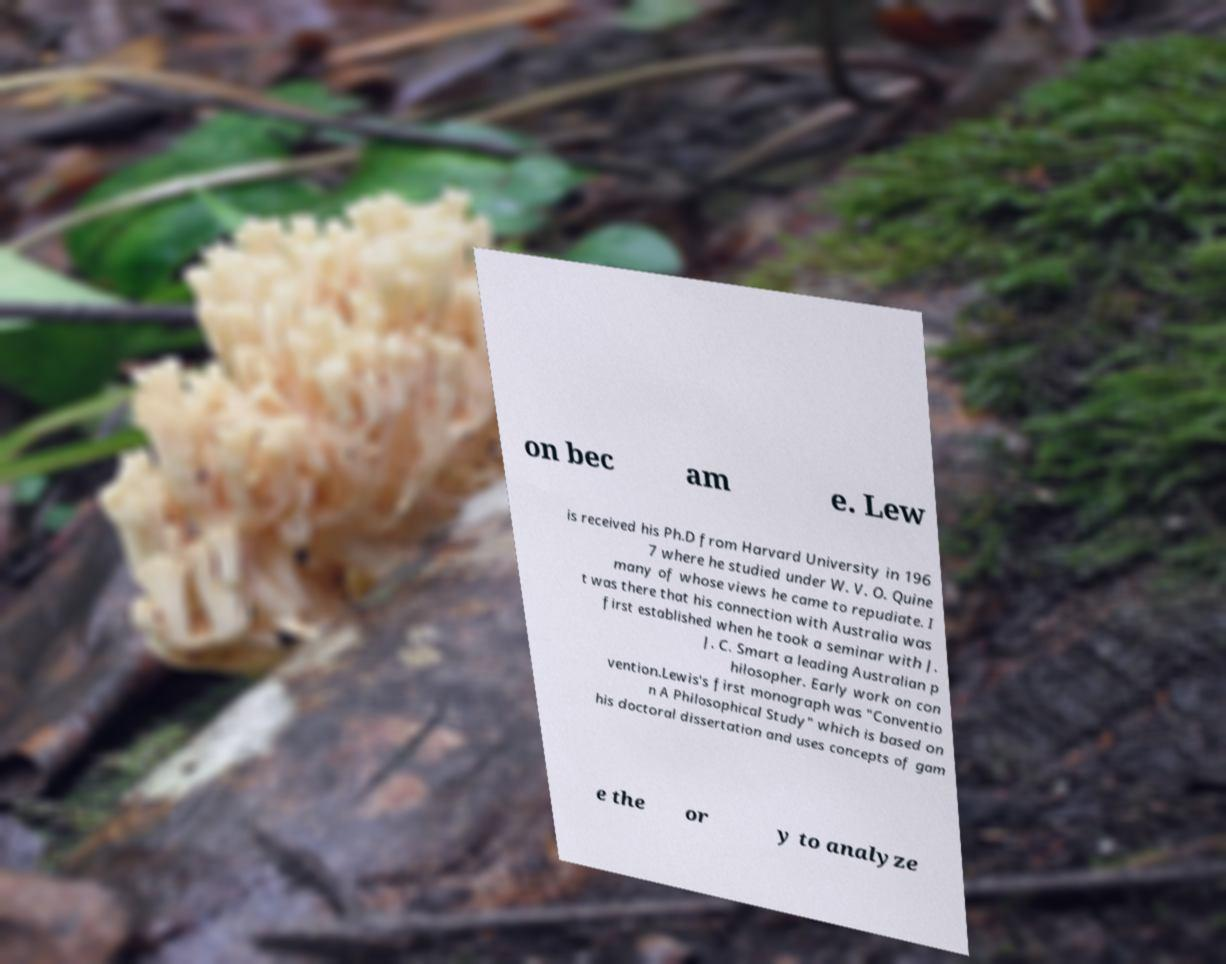Can you accurately transcribe the text from the provided image for me? on bec am e. Lew is received his Ph.D from Harvard University in 196 7 where he studied under W. V. O. Quine many of whose views he came to repudiate. I t was there that his connection with Australia was first established when he took a seminar with J. J. C. Smart a leading Australian p hilosopher. Early work on con vention.Lewis's first monograph was "Conventio n A Philosophical Study" which is based on his doctoral dissertation and uses concepts of gam e the or y to analyze 